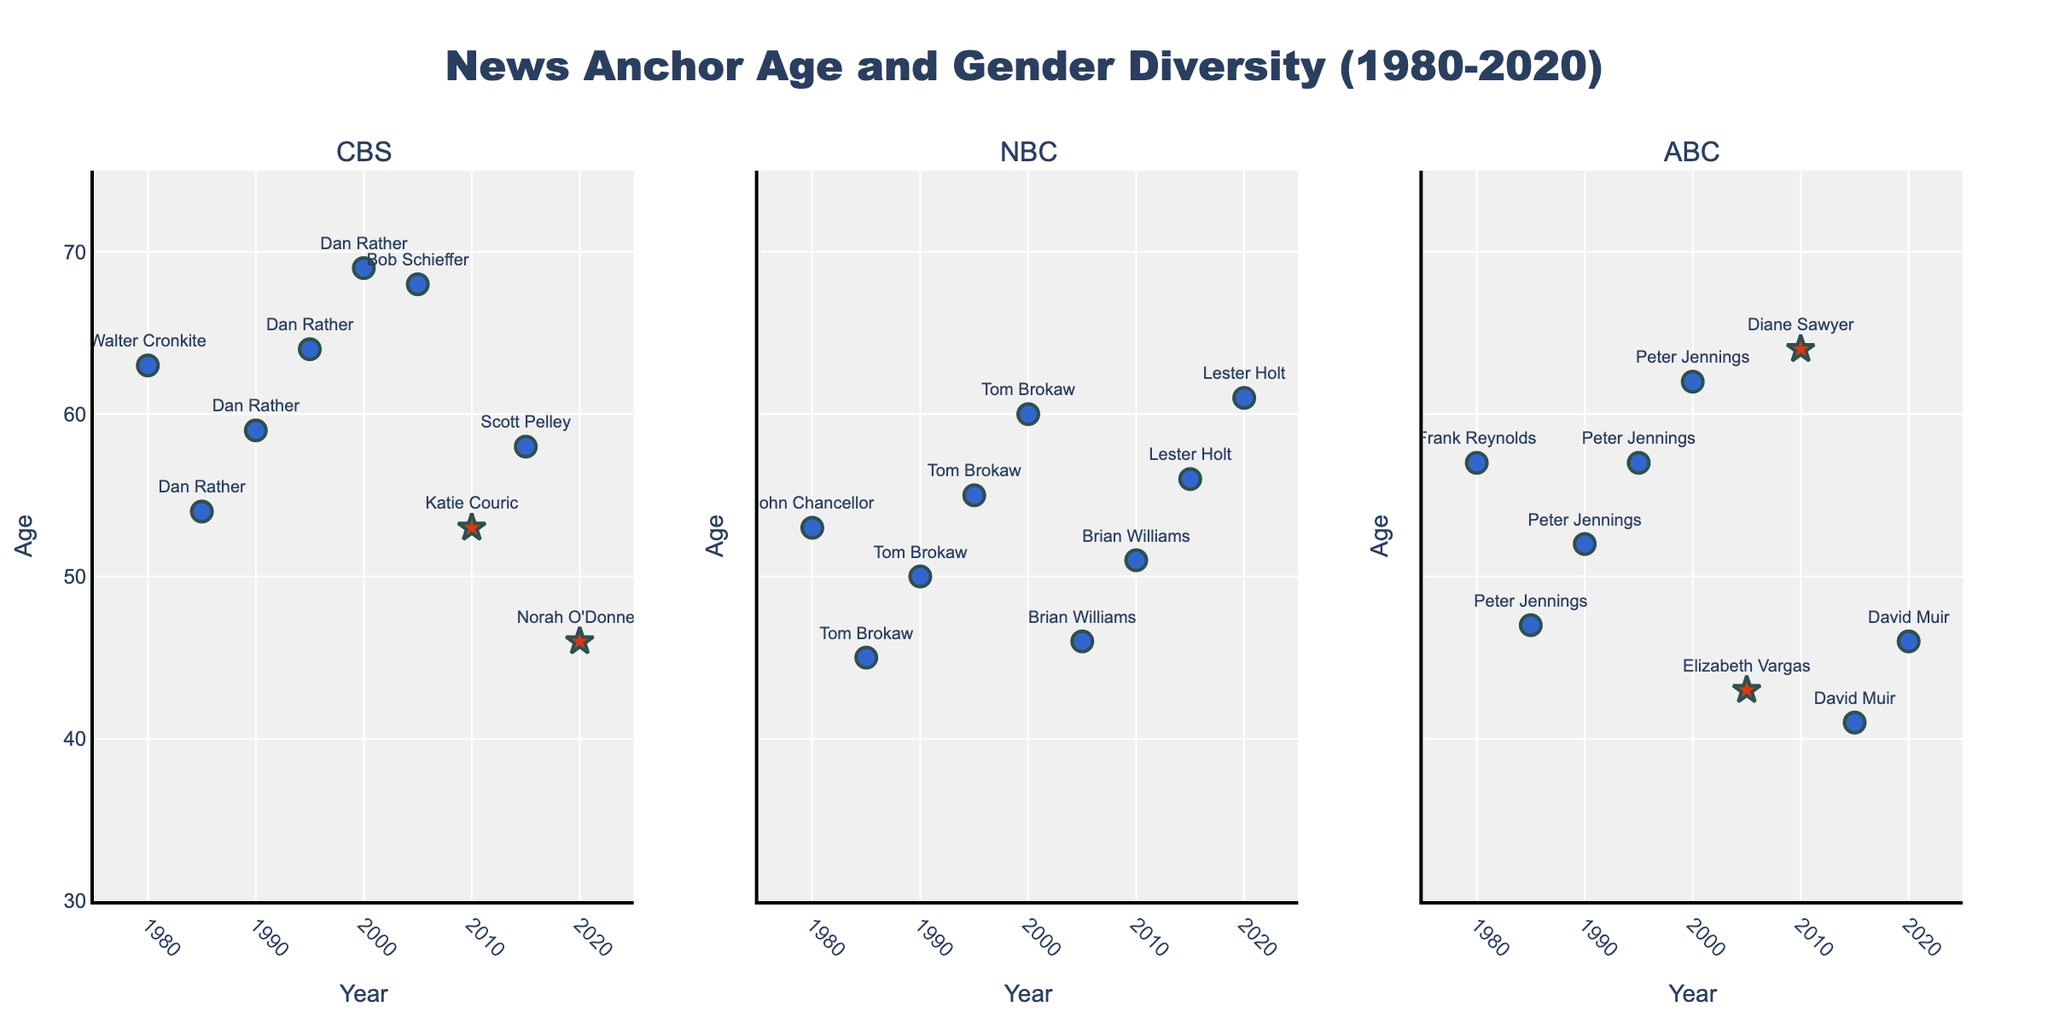What is the title of the figure? The title of the figure is displayed at the top and reads "News Anchor Age and Gender Diversity (1980-2020)".
Answer: News Anchor Age and Gender Diversity (1980-2020) What does the Y-axis represent? The Y-axis represents the age of the news anchors. This is visible as it is labeled "Age" on the Y-axis of the plots.
Answer: Age Which network had the first female anchor? The first female anchor appears in the ABC subplot in the year 2005. Her name is Elizabeth Vargas.
Answer: ABC How many female anchors are shown in the data from 1980 to 2020? To find the number of female anchors, we count the star symbols in the plots because stars represent female anchors. There are 5 star symbols, hence 5 female anchors.
Answer: 5 Which network had the oldest news anchor in 2020? The CBS subplot shows an anchor at age 46 (Norah O'Donnell), NBC shows an anchor at age 61 (Lester Holt), and ABC shows an anchor at age 46 (David Muir). Therefore, NBC had the oldest news anchor in 2020.
Answer: NBC What is the age difference between the oldest and youngest anchors in 2005? CBS had Bob Schieffer at 68, NBC had Brian Williams at 46, and ABC had Elizabeth Vargas at 43. The difference between the oldest (68) and youngest (43) is 68 - 43 = 25.
Answer: 25 Which gender has more diversity in age across all networks? Males have a more diverse age range. By observing the plots, it is evident that male anchors' ages vary from their 40s to their 60s and 70s, whereas female anchors range from their 40s to 60s only.
Answer: Male During which decade did CBS have the most significant decrease in the average age of its news anchors? From 1980 to 2020, CBS's anchor ages were 63, 54, 59, 64, 69, 68, 53, 58, and 46. The most significant average decrease over a decade is between 2000 (69) and 2010 (53). The difference is 16 years.
Answer: 2000s to 2010s What is the most common age range for male anchors across all networks? Observing the plots, the majority of male anchors' ages are commonly between 50 and 60 years.
Answer: 50-60 Which network shows the greatest variation in anchor ages over the years? By comparing the age ranges in each subplot, CBS shows a range from the early 40s to the upper 60s over the years, indicating significant variation compared to the other networks.
Answer: CBS 